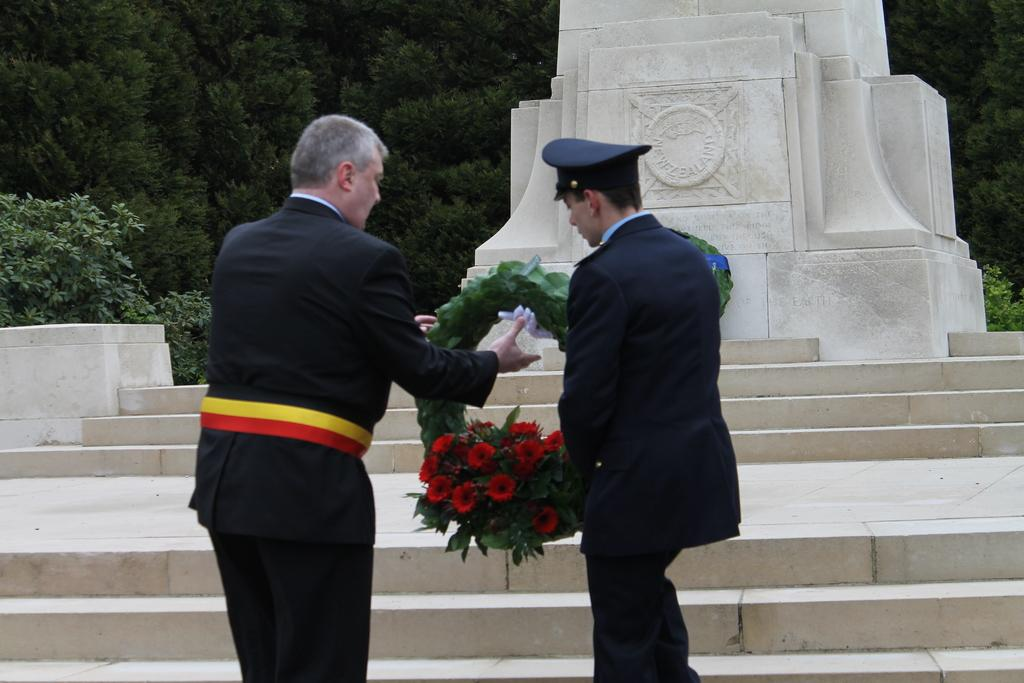How many people are in the image? There are two persons standing in the middle of the image. What are the two persons holding? The two persons are holding a bouquet. What is in front of the two persons? There are steps and a sculpture in front of the two persons. What can be seen behind the two persons? There are trees visible behind the two persons. What type of insurance policy is being discussed by the two persons in the image? There is no indication in the image that the two persons are discussing any insurance policies. 